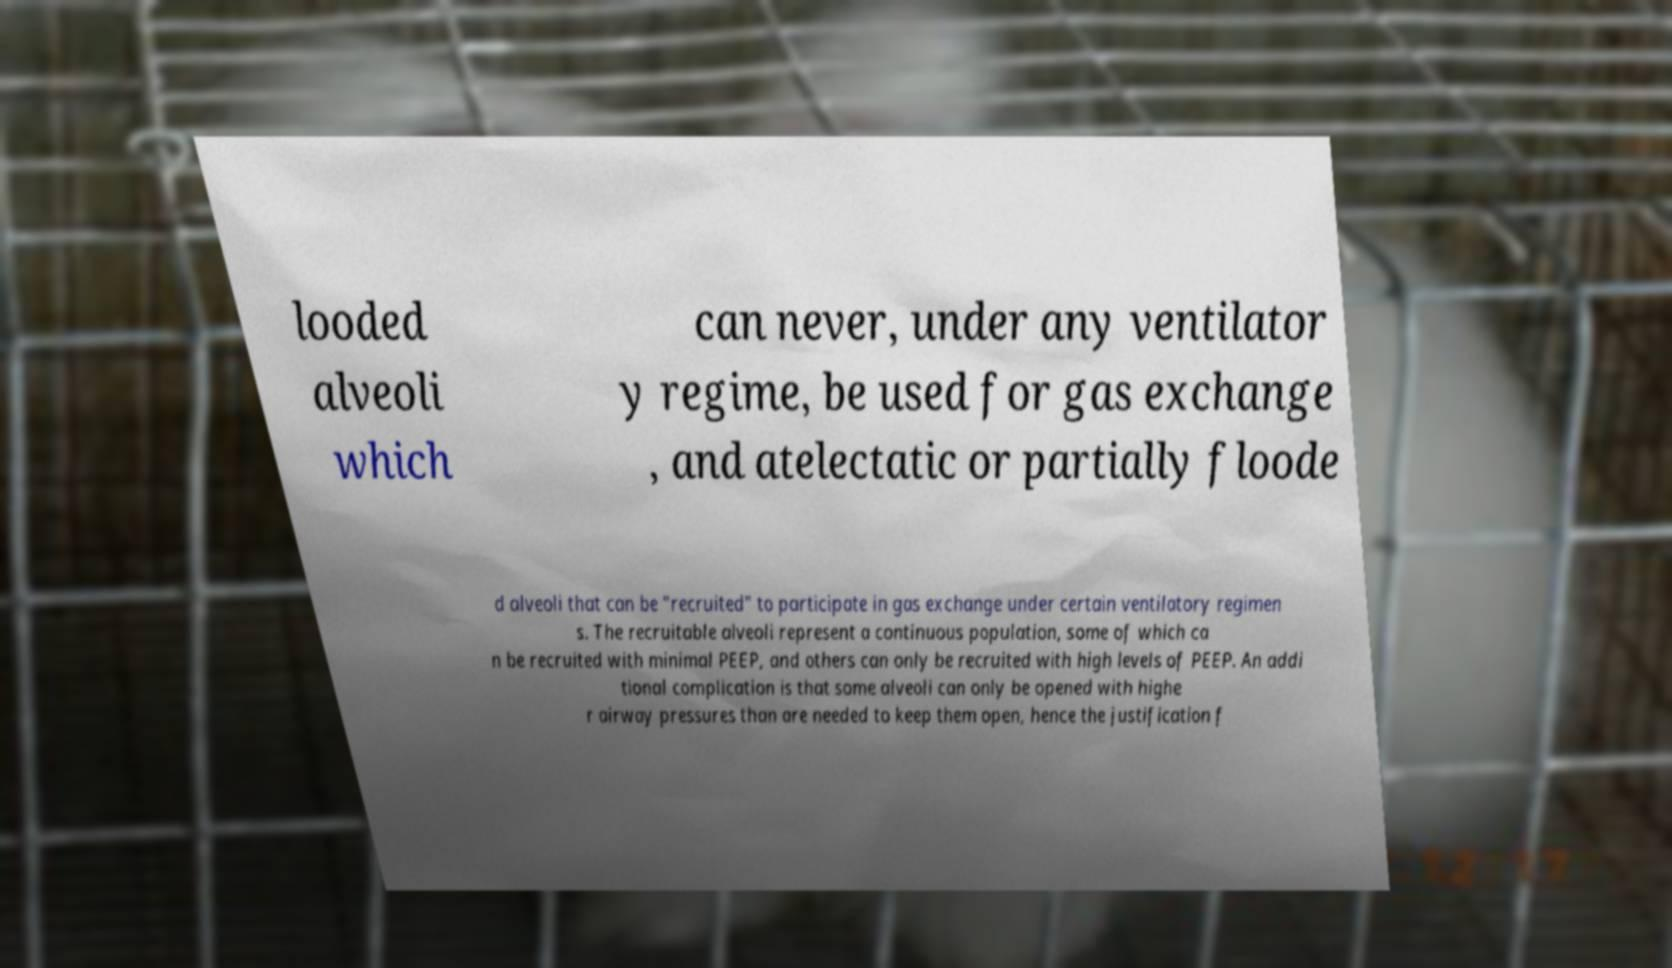Please read and relay the text visible in this image. What does it say? looded alveoli which can never, under any ventilator y regime, be used for gas exchange , and atelectatic or partially floode d alveoli that can be "recruited" to participate in gas exchange under certain ventilatory regimen s. The recruitable alveoli represent a continuous population, some of which ca n be recruited with minimal PEEP, and others can only be recruited with high levels of PEEP. An addi tional complication is that some alveoli can only be opened with highe r airway pressures than are needed to keep them open, hence the justification f 